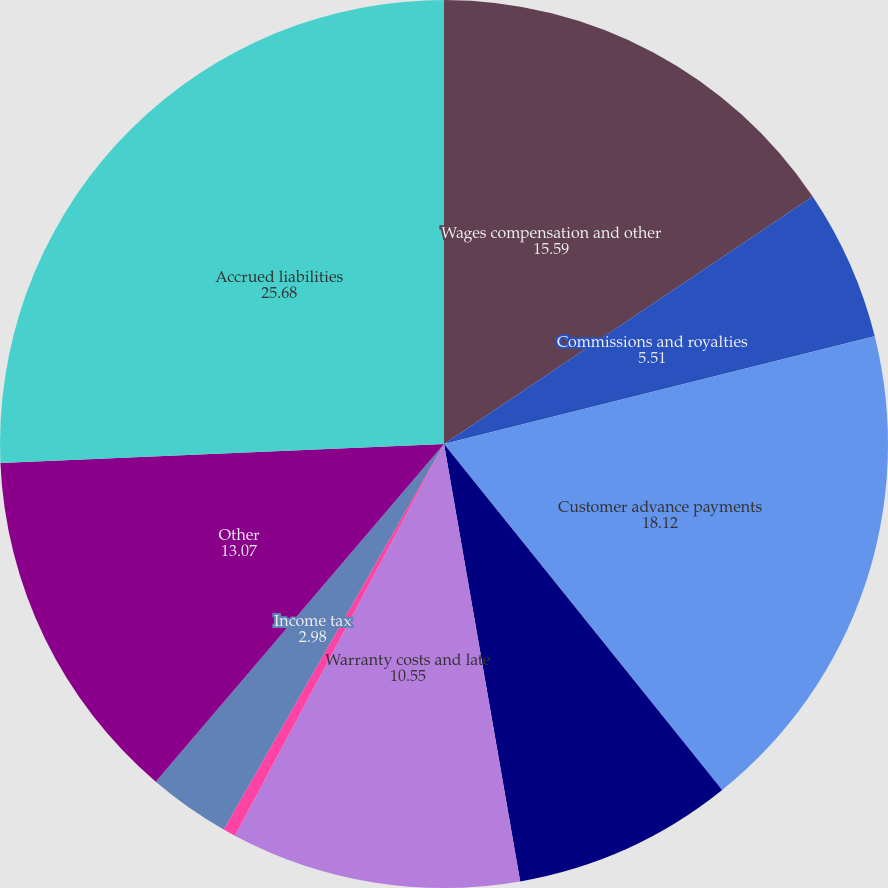<chart> <loc_0><loc_0><loc_500><loc_500><pie_chart><fcel>Wages compensation and other<fcel>Commissions and royalties<fcel>Customer advance payments<fcel>Progress billings in excess of<fcel>Warranty costs and late<fcel>Sales and use tax<fcel>Income tax<fcel>Other<fcel>Accrued liabilities<nl><fcel>15.59%<fcel>5.51%<fcel>18.12%<fcel>8.03%<fcel>10.55%<fcel>0.46%<fcel>2.98%<fcel>13.07%<fcel>25.68%<nl></chart> 